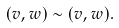<formula> <loc_0><loc_0><loc_500><loc_500>( v , w ) \sim ( v , w ) .</formula> 